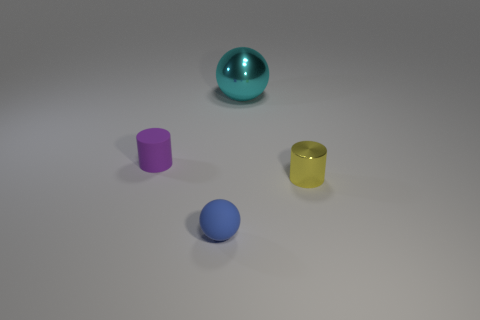Add 4 spheres. How many objects exist? 8 Subtract 0 blue cubes. How many objects are left? 4 Subtract all small brown cubes. Subtract all small purple matte cylinders. How many objects are left? 3 Add 1 cyan objects. How many cyan objects are left? 2 Add 1 cyan metallic objects. How many cyan metallic objects exist? 2 